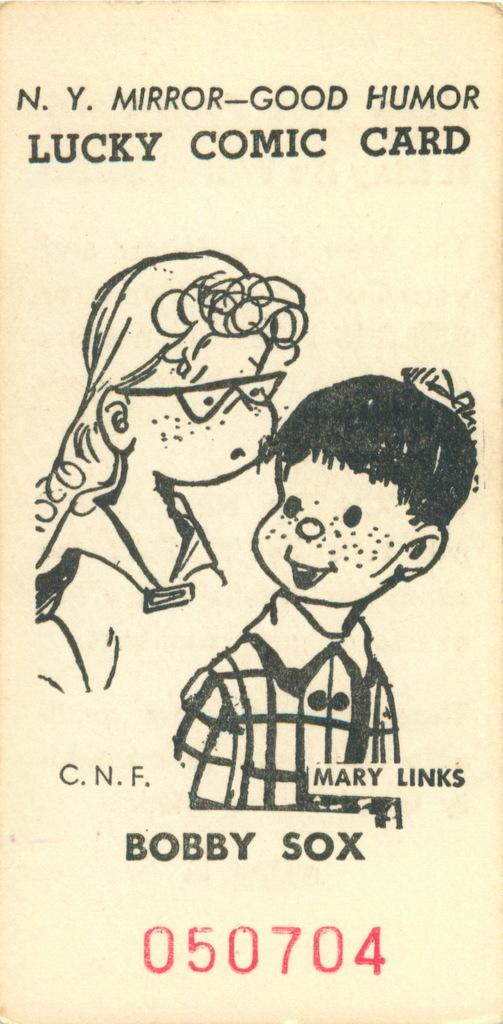What is depicted on the paper in the image? There are drawings of two people on the paper. What else can be found on the paper besides the drawings? There are words and numbers on the paper. What type of horn is being used by one of the people in the drawing? There is no horn present in the drawing; it only depicts two people. 